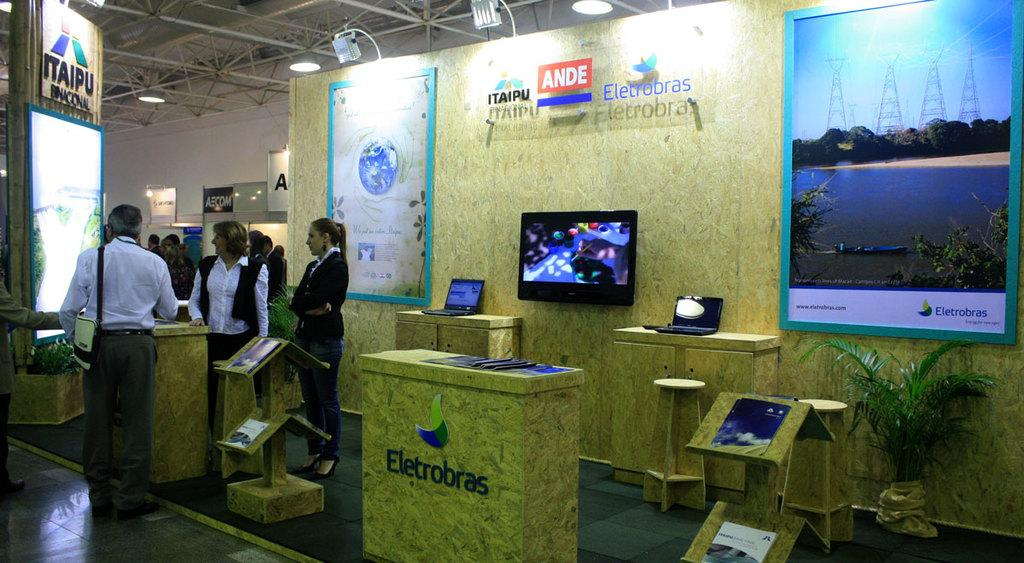<image>
Describe the image concisely. A convention type setting with representatives from Ande Eletrobras. 